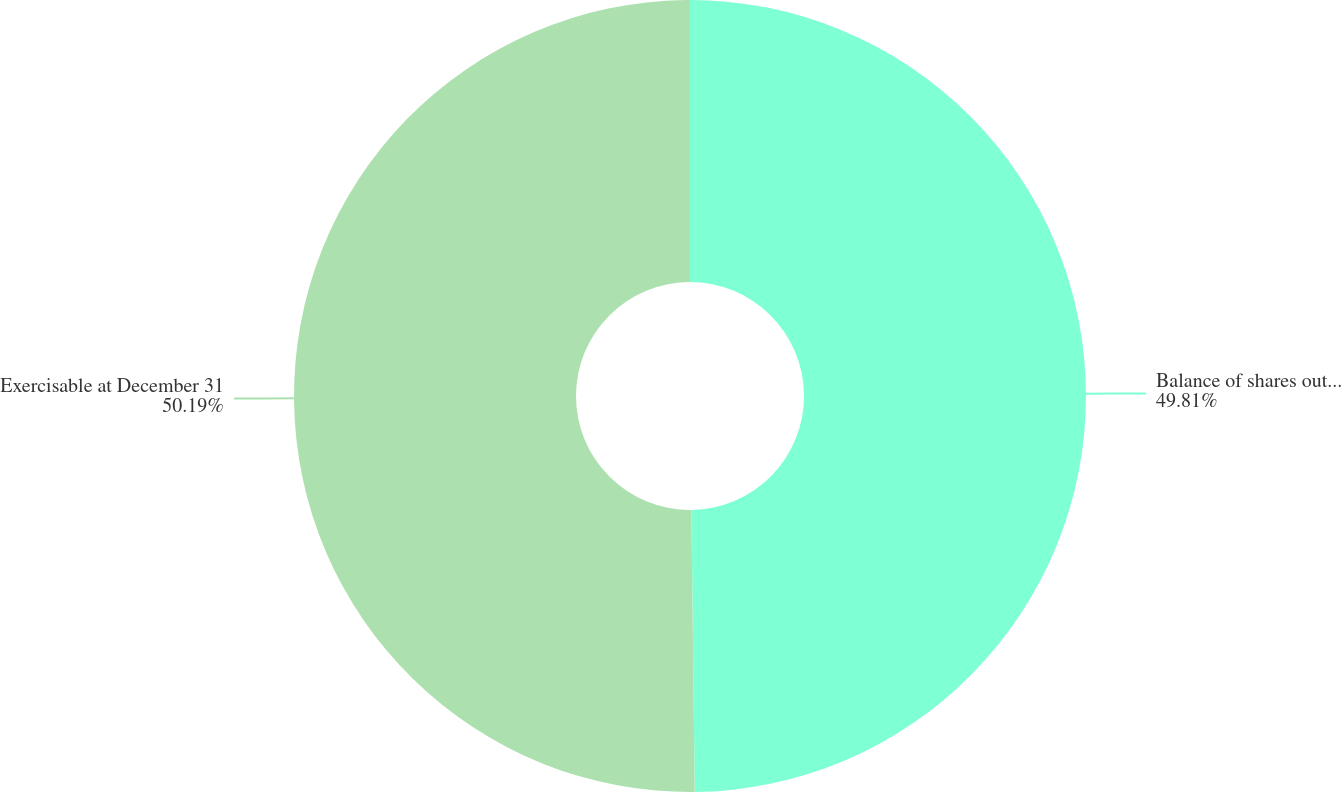Convert chart to OTSL. <chart><loc_0><loc_0><loc_500><loc_500><pie_chart><fcel>Balance of shares outstanding<fcel>Exercisable at December 31<nl><fcel>49.81%<fcel>50.19%<nl></chart> 